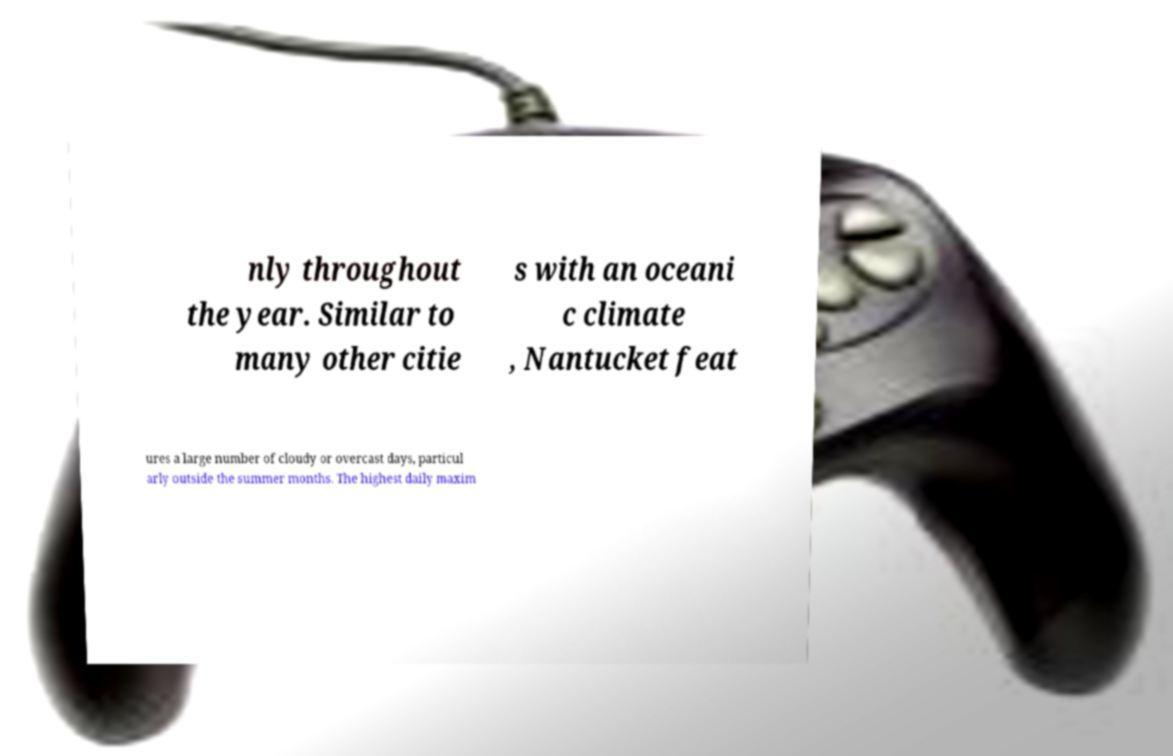What messages or text are displayed in this image? I need them in a readable, typed format. nly throughout the year. Similar to many other citie s with an oceani c climate , Nantucket feat ures a large number of cloudy or overcast days, particul arly outside the summer months. The highest daily maxim 